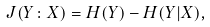Convert formula to latex. <formula><loc_0><loc_0><loc_500><loc_500>J ( Y \colon X ) = H ( Y ) - H ( Y | X ) ,</formula> 